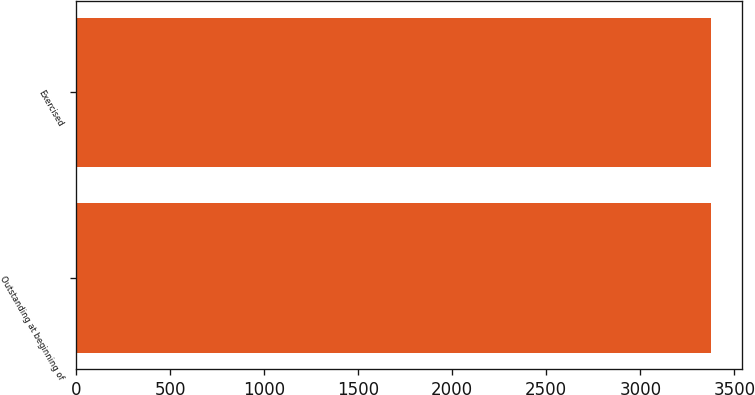Convert chart to OTSL. <chart><loc_0><loc_0><loc_500><loc_500><bar_chart><fcel>Outstanding at beginning of<fcel>Exercised<nl><fcel>3375<fcel>3375.1<nl></chart> 